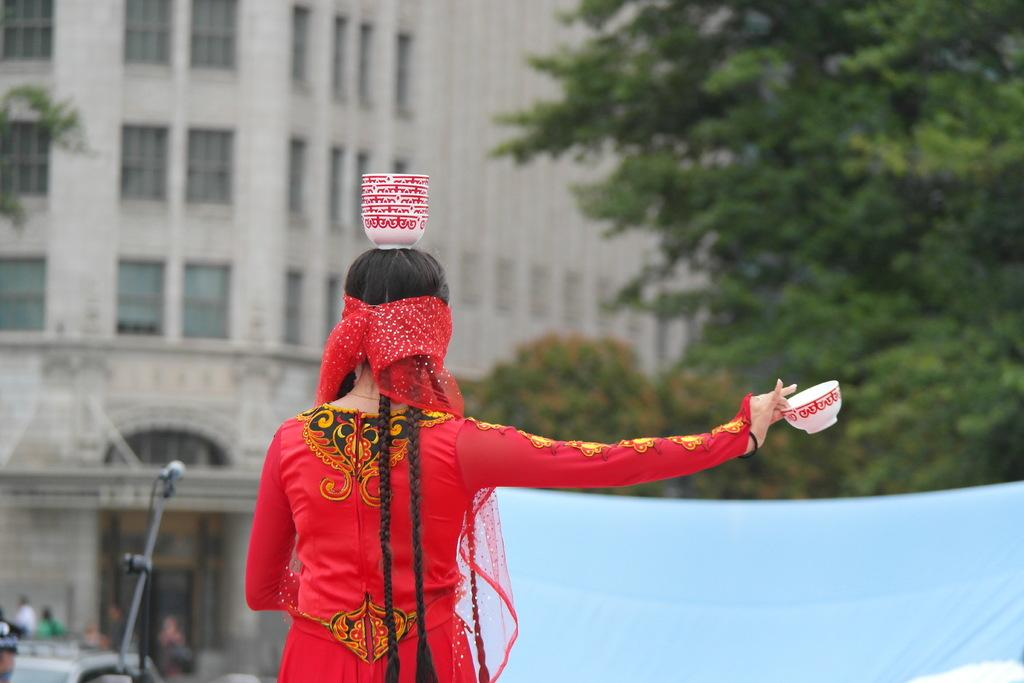Who is the main subject in the image? There is a woman in the image. What is the woman doing with the cup? The woman is holding a cup on her head. What else is the woman holding in the image? The woman is holding a bowl with her hand. What can be seen in the background of the image? There is a building with windows, a mic with a stand, and trees in the background. What type of queen can be seen riding a donkey in the image? There is no queen or donkey present in the image. Is there a goat visible in the image? No, there is no goat present in the image. 